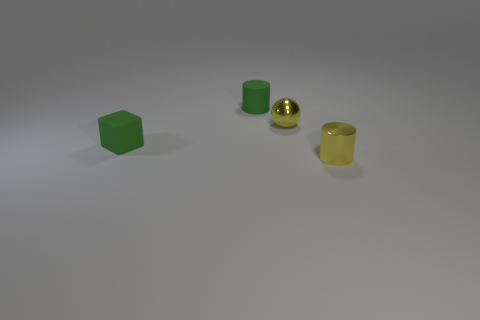Subtract all purple blocks. Subtract all red spheres. How many blocks are left? 1 Add 4 yellow shiny objects. How many objects exist? 8 Subtract all cubes. How many objects are left? 3 Subtract 1 green cubes. How many objects are left? 3 Subtract all green cubes. Subtract all tiny blocks. How many objects are left? 2 Add 4 green matte cubes. How many green matte cubes are left? 5 Add 3 purple matte things. How many purple matte things exist? 3 